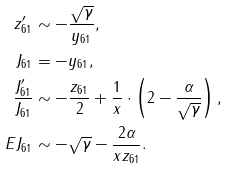Convert formula to latex. <formula><loc_0><loc_0><loc_500><loc_500>z _ { 6 1 } ^ { \prime } & \sim - \frac { \sqrt { \gamma } } { y _ { 6 1 } } , \\ J _ { 6 1 } & = - y _ { 6 1 } , \\ \frac { J _ { 6 1 } ^ { \prime } } { J _ { 6 1 } } & \sim - \frac { z _ { 6 1 } } { 2 } + \frac { 1 } { x } \cdot \left ( 2 - \frac { \alpha } { \sqrt { \gamma } } \right ) , \\ E J _ { 6 1 } & \sim - \sqrt { \gamma } - \frac { 2 \alpha } { x z _ { 6 1 } } .</formula> 